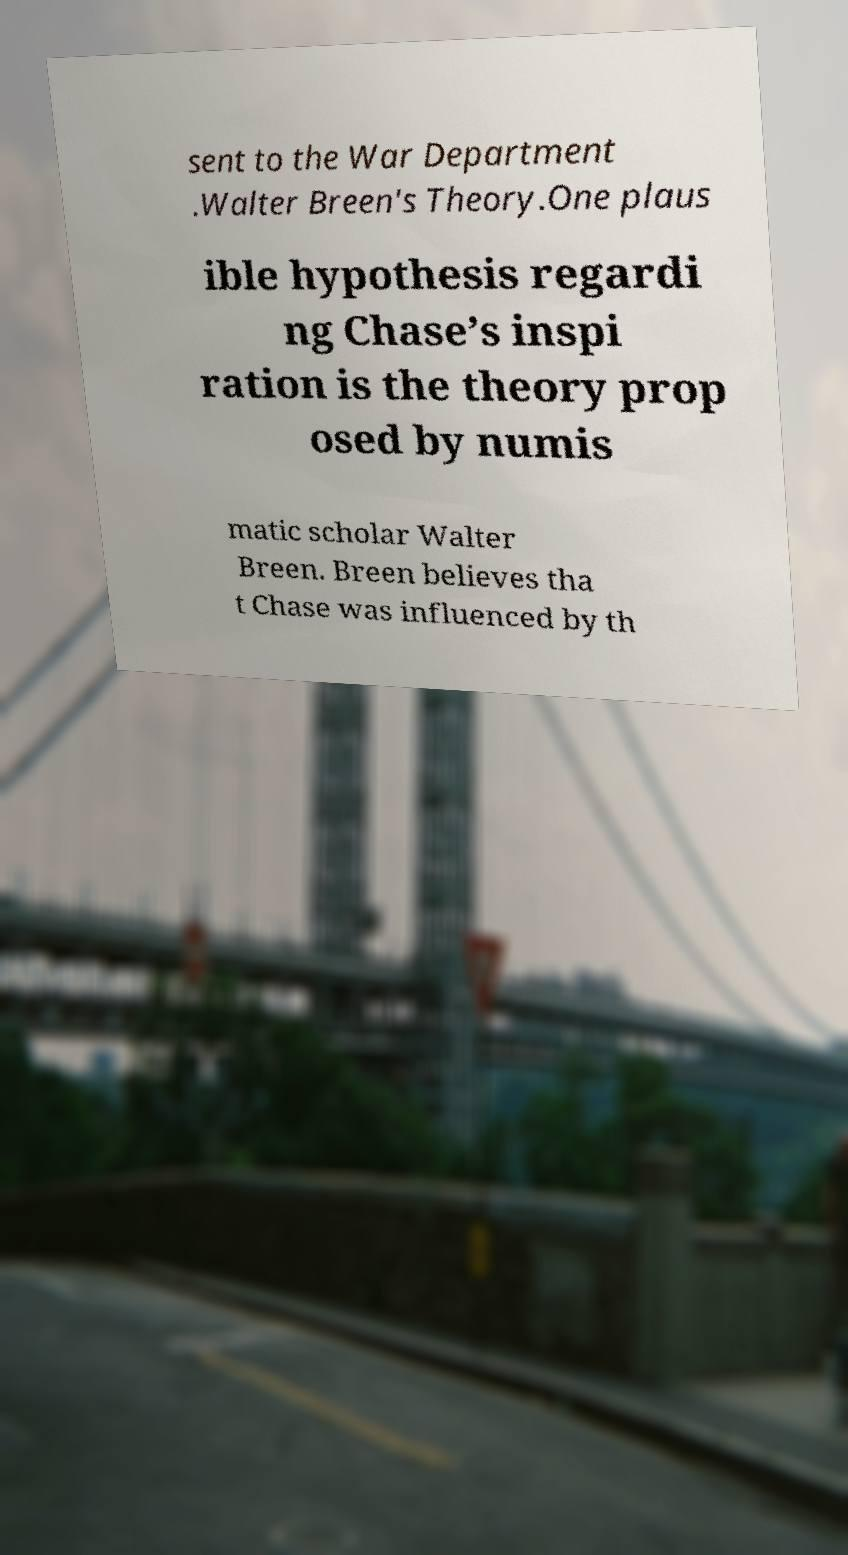Could you extract and type out the text from this image? sent to the War Department .Walter Breen's Theory.One plaus ible hypothesis regardi ng Chase’s inspi ration is the theory prop osed by numis matic scholar Walter Breen. Breen believes tha t Chase was influenced by th 